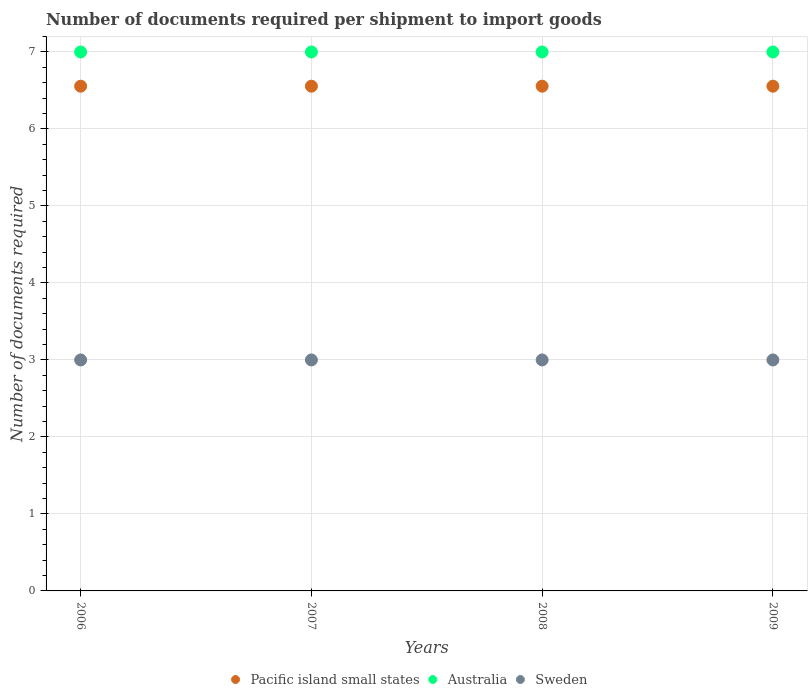How many different coloured dotlines are there?
Ensure brevity in your answer.  3. What is the number of documents required per shipment to import goods in Australia in 2008?
Provide a succinct answer. 7. Across all years, what is the maximum number of documents required per shipment to import goods in Sweden?
Make the answer very short. 3. Across all years, what is the minimum number of documents required per shipment to import goods in Sweden?
Offer a very short reply. 3. In which year was the number of documents required per shipment to import goods in Sweden minimum?
Give a very brief answer. 2006. What is the total number of documents required per shipment to import goods in Sweden in the graph?
Your answer should be compact. 12. What is the difference between the number of documents required per shipment to import goods in Sweden in 2006 and the number of documents required per shipment to import goods in Australia in 2007?
Ensure brevity in your answer.  -4. What is the average number of documents required per shipment to import goods in Sweden per year?
Your answer should be compact. 3. In the year 2009, what is the difference between the number of documents required per shipment to import goods in Pacific island small states and number of documents required per shipment to import goods in Sweden?
Make the answer very short. 3.56. What is the ratio of the number of documents required per shipment to import goods in Australia in 2008 to that in 2009?
Ensure brevity in your answer.  1. Is the number of documents required per shipment to import goods in Pacific island small states in 2006 less than that in 2007?
Ensure brevity in your answer.  No. What is the difference between the highest and the lowest number of documents required per shipment to import goods in Sweden?
Your answer should be very brief. 0. In how many years, is the number of documents required per shipment to import goods in Sweden greater than the average number of documents required per shipment to import goods in Sweden taken over all years?
Your response must be concise. 0. Is it the case that in every year, the sum of the number of documents required per shipment to import goods in Sweden and number of documents required per shipment to import goods in Australia  is greater than the number of documents required per shipment to import goods in Pacific island small states?
Your answer should be compact. Yes. How many dotlines are there?
Offer a very short reply. 3. Are the values on the major ticks of Y-axis written in scientific E-notation?
Make the answer very short. No. Does the graph contain any zero values?
Provide a short and direct response. No. Where does the legend appear in the graph?
Keep it short and to the point. Bottom center. How many legend labels are there?
Your answer should be very brief. 3. How are the legend labels stacked?
Offer a very short reply. Horizontal. What is the title of the graph?
Offer a terse response. Number of documents required per shipment to import goods. What is the label or title of the X-axis?
Make the answer very short. Years. What is the label or title of the Y-axis?
Your answer should be compact. Number of documents required. What is the Number of documents required in Pacific island small states in 2006?
Give a very brief answer. 6.56. What is the Number of documents required of Pacific island small states in 2007?
Offer a very short reply. 6.56. What is the Number of documents required of Australia in 2007?
Keep it short and to the point. 7. What is the Number of documents required in Sweden in 2007?
Offer a very short reply. 3. What is the Number of documents required of Pacific island small states in 2008?
Give a very brief answer. 6.56. What is the Number of documents required in Australia in 2008?
Offer a very short reply. 7. What is the Number of documents required in Pacific island small states in 2009?
Provide a succinct answer. 6.56. Across all years, what is the maximum Number of documents required of Pacific island small states?
Offer a terse response. 6.56. Across all years, what is the minimum Number of documents required in Pacific island small states?
Your answer should be compact. 6.56. Across all years, what is the minimum Number of documents required of Australia?
Your answer should be compact. 7. Across all years, what is the minimum Number of documents required in Sweden?
Provide a succinct answer. 3. What is the total Number of documents required of Pacific island small states in the graph?
Your response must be concise. 26.22. What is the total Number of documents required in Australia in the graph?
Offer a terse response. 28. What is the total Number of documents required of Sweden in the graph?
Provide a succinct answer. 12. What is the difference between the Number of documents required of Sweden in 2006 and that in 2007?
Your answer should be very brief. 0. What is the difference between the Number of documents required of Pacific island small states in 2006 and that in 2008?
Your response must be concise. 0. What is the difference between the Number of documents required in Sweden in 2006 and that in 2008?
Offer a terse response. 0. What is the difference between the Number of documents required of Pacific island small states in 2006 and that in 2009?
Provide a succinct answer. 0. What is the difference between the Number of documents required in Sweden in 2006 and that in 2009?
Your response must be concise. 0. What is the difference between the Number of documents required of Pacific island small states in 2007 and that in 2008?
Provide a short and direct response. 0. What is the difference between the Number of documents required of Pacific island small states in 2007 and that in 2009?
Your answer should be compact. 0. What is the difference between the Number of documents required of Sweden in 2007 and that in 2009?
Make the answer very short. 0. What is the difference between the Number of documents required in Australia in 2008 and that in 2009?
Give a very brief answer. 0. What is the difference between the Number of documents required of Sweden in 2008 and that in 2009?
Your answer should be compact. 0. What is the difference between the Number of documents required of Pacific island small states in 2006 and the Number of documents required of Australia in 2007?
Ensure brevity in your answer.  -0.44. What is the difference between the Number of documents required of Pacific island small states in 2006 and the Number of documents required of Sweden in 2007?
Keep it short and to the point. 3.56. What is the difference between the Number of documents required of Australia in 2006 and the Number of documents required of Sweden in 2007?
Offer a terse response. 4. What is the difference between the Number of documents required of Pacific island small states in 2006 and the Number of documents required of Australia in 2008?
Your answer should be compact. -0.44. What is the difference between the Number of documents required in Pacific island small states in 2006 and the Number of documents required in Sweden in 2008?
Make the answer very short. 3.56. What is the difference between the Number of documents required of Australia in 2006 and the Number of documents required of Sweden in 2008?
Keep it short and to the point. 4. What is the difference between the Number of documents required in Pacific island small states in 2006 and the Number of documents required in Australia in 2009?
Give a very brief answer. -0.44. What is the difference between the Number of documents required of Pacific island small states in 2006 and the Number of documents required of Sweden in 2009?
Your response must be concise. 3.56. What is the difference between the Number of documents required of Australia in 2006 and the Number of documents required of Sweden in 2009?
Offer a terse response. 4. What is the difference between the Number of documents required in Pacific island small states in 2007 and the Number of documents required in Australia in 2008?
Offer a terse response. -0.44. What is the difference between the Number of documents required in Pacific island small states in 2007 and the Number of documents required in Sweden in 2008?
Ensure brevity in your answer.  3.56. What is the difference between the Number of documents required of Australia in 2007 and the Number of documents required of Sweden in 2008?
Make the answer very short. 4. What is the difference between the Number of documents required in Pacific island small states in 2007 and the Number of documents required in Australia in 2009?
Provide a succinct answer. -0.44. What is the difference between the Number of documents required of Pacific island small states in 2007 and the Number of documents required of Sweden in 2009?
Keep it short and to the point. 3.56. What is the difference between the Number of documents required of Australia in 2007 and the Number of documents required of Sweden in 2009?
Your answer should be compact. 4. What is the difference between the Number of documents required of Pacific island small states in 2008 and the Number of documents required of Australia in 2009?
Your response must be concise. -0.44. What is the difference between the Number of documents required of Pacific island small states in 2008 and the Number of documents required of Sweden in 2009?
Give a very brief answer. 3.56. What is the average Number of documents required of Pacific island small states per year?
Provide a succinct answer. 6.56. What is the average Number of documents required in Sweden per year?
Provide a succinct answer. 3. In the year 2006, what is the difference between the Number of documents required in Pacific island small states and Number of documents required in Australia?
Provide a succinct answer. -0.44. In the year 2006, what is the difference between the Number of documents required in Pacific island small states and Number of documents required in Sweden?
Provide a succinct answer. 3.56. In the year 2007, what is the difference between the Number of documents required of Pacific island small states and Number of documents required of Australia?
Provide a succinct answer. -0.44. In the year 2007, what is the difference between the Number of documents required in Pacific island small states and Number of documents required in Sweden?
Make the answer very short. 3.56. In the year 2007, what is the difference between the Number of documents required of Australia and Number of documents required of Sweden?
Your response must be concise. 4. In the year 2008, what is the difference between the Number of documents required of Pacific island small states and Number of documents required of Australia?
Your answer should be compact. -0.44. In the year 2008, what is the difference between the Number of documents required in Pacific island small states and Number of documents required in Sweden?
Provide a succinct answer. 3.56. In the year 2008, what is the difference between the Number of documents required of Australia and Number of documents required of Sweden?
Give a very brief answer. 4. In the year 2009, what is the difference between the Number of documents required of Pacific island small states and Number of documents required of Australia?
Your response must be concise. -0.44. In the year 2009, what is the difference between the Number of documents required in Pacific island small states and Number of documents required in Sweden?
Offer a terse response. 3.56. In the year 2009, what is the difference between the Number of documents required of Australia and Number of documents required of Sweden?
Keep it short and to the point. 4. What is the ratio of the Number of documents required of Australia in 2006 to that in 2007?
Provide a succinct answer. 1. What is the ratio of the Number of documents required of Australia in 2006 to that in 2008?
Give a very brief answer. 1. What is the ratio of the Number of documents required in Sweden in 2006 to that in 2008?
Keep it short and to the point. 1. What is the ratio of the Number of documents required of Pacific island small states in 2006 to that in 2009?
Your response must be concise. 1. What is the ratio of the Number of documents required of Pacific island small states in 2007 to that in 2008?
Make the answer very short. 1. What is the ratio of the Number of documents required of Pacific island small states in 2007 to that in 2009?
Your answer should be compact. 1. What is the ratio of the Number of documents required of Australia in 2007 to that in 2009?
Offer a terse response. 1. What is the ratio of the Number of documents required of Sweden in 2008 to that in 2009?
Offer a terse response. 1. What is the difference between the highest and the second highest Number of documents required of Sweden?
Ensure brevity in your answer.  0. 